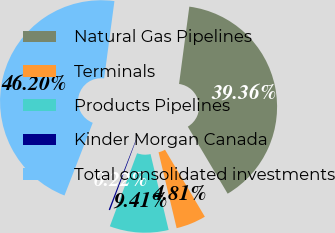Convert chart. <chart><loc_0><loc_0><loc_500><loc_500><pie_chart><fcel>Natural Gas Pipelines<fcel>Terminals<fcel>Products Pipelines<fcel>Kinder Morgan Canada<fcel>Total consolidated investments<nl><fcel>39.36%<fcel>4.81%<fcel>9.41%<fcel>0.22%<fcel>46.2%<nl></chart> 